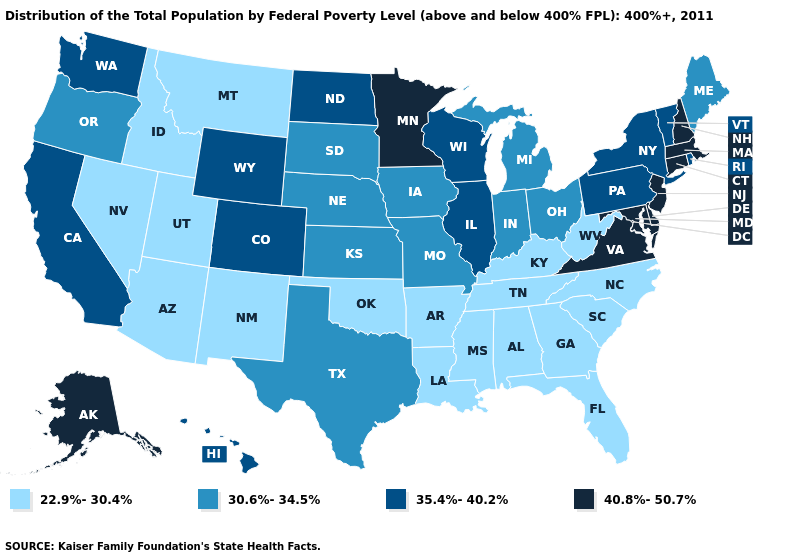What is the value of Oklahoma?
Concise answer only. 22.9%-30.4%. What is the lowest value in states that border Rhode Island?
Answer briefly. 40.8%-50.7%. What is the lowest value in the USA?
Short answer required. 22.9%-30.4%. Does Washington have a lower value than Wyoming?
Concise answer only. No. Among the states that border South Dakota , does Montana have the lowest value?
Answer briefly. Yes. Which states hav the highest value in the South?
Concise answer only. Delaware, Maryland, Virginia. What is the value of Maryland?
Answer briefly. 40.8%-50.7%. What is the value of Idaho?
Concise answer only. 22.9%-30.4%. Which states have the highest value in the USA?
Be succinct. Alaska, Connecticut, Delaware, Maryland, Massachusetts, Minnesota, New Hampshire, New Jersey, Virginia. Name the states that have a value in the range 30.6%-34.5%?
Write a very short answer. Indiana, Iowa, Kansas, Maine, Michigan, Missouri, Nebraska, Ohio, Oregon, South Dakota, Texas. Does Maine have the highest value in the USA?
Quick response, please. No. Does the map have missing data?
Answer briefly. No. Among the states that border South Carolina , which have the lowest value?
Concise answer only. Georgia, North Carolina. What is the value of Oklahoma?
Give a very brief answer. 22.9%-30.4%. What is the value of Idaho?
Answer briefly. 22.9%-30.4%. 